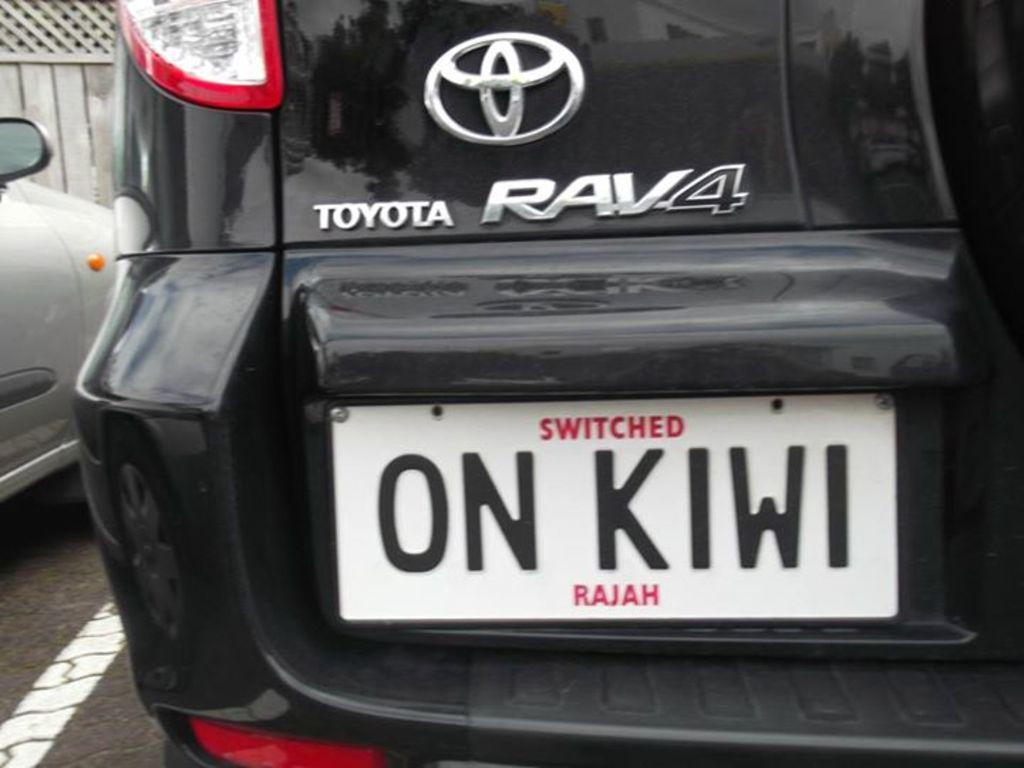<image>
Write a terse but informative summary of the picture. A black car says Toyota RAV4 on the back. 